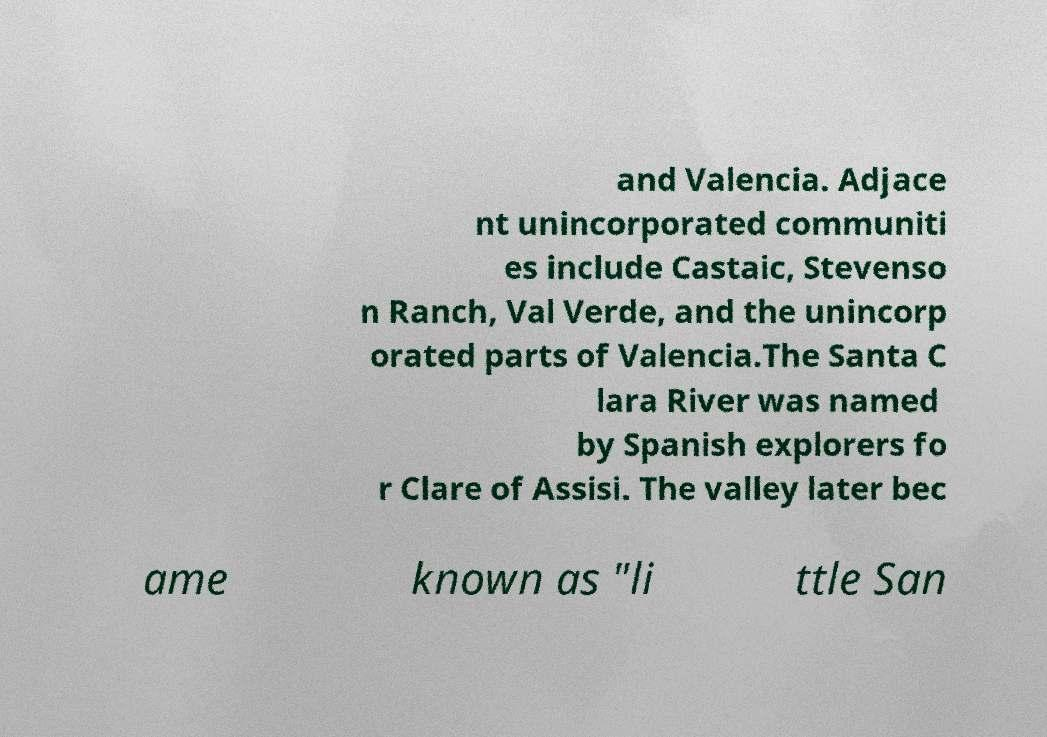For documentation purposes, I need the text within this image transcribed. Could you provide that? and Valencia. Adjace nt unincorporated communiti es include Castaic, Stevenso n Ranch, Val Verde, and the unincorp orated parts of Valencia.The Santa C lara River was named by Spanish explorers fo r Clare of Assisi. The valley later bec ame known as "li ttle San 